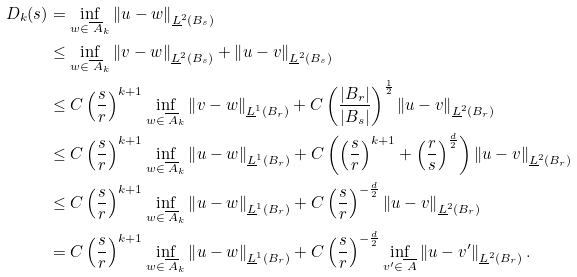Convert formula to latex. <formula><loc_0><loc_0><loc_500><loc_500>D _ { k } ( s ) & = \inf _ { w \in \overline { \ A } _ { k } } \left \| u - w \right \| _ { \underline { L } ^ { 2 } ( B _ { s } ) } \\ & \leq \inf _ { w \in \overline { \ A } _ { k } } \left \| v - w \right \| _ { \underline { L } ^ { 2 } ( B _ { s } ) } + \left \| u - v \right \| _ { \underline { L } ^ { 2 } ( B _ { s } ) } \\ & \leq C \left ( \frac { s } { r } \right ) ^ { k + 1 } \inf _ { w \in \overline { \ A } _ { k } } \left \| v - w \right \| _ { \underline { L } ^ { 1 } ( B _ { r } ) } + C \left ( \frac { | B _ { r } | } { | B _ { s } | } \right ) ^ { \frac { 1 } { 2 } } \left \| u - v \right \| _ { \underline { L } ^ { 2 } ( B _ { r } ) } \\ & \leq C \left ( \frac { s } { r } \right ) ^ { k + 1 } \inf _ { w \in \overline { \ A } _ { k } } \left \| u - w \right \| _ { \underline { L } ^ { 1 } ( B _ { r } ) } + C \left ( \left ( \frac { s } { r } \right ) ^ { k + 1 } + \left ( \frac { r } { s } \right ) ^ { \frac { d } { 2 } } \right ) \left \| u - v \right \| _ { \underline { L } ^ { 2 } ( B _ { r } ) } \\ & \leq C \left ( \frac { s } { r } \right ) ^ { k + 1 } \inf _ { w \in \overline { \ A } _ { k } } \left \| u - w \right \| _ { \underline { L } ^ { 1 } ( B _ { r } ) } + C \left ( \frac { s } { r } \right ) ^ { - \frac { d } { 2 } } \left \| u - v \right \| _ { \underline { L } ^ { 2 } ( B _ { r } ) } \\ & = C \left ( \frac { s } { r } \right ) ^ { k + 1 } \inf _ { w \in \overline { \ A } _ { k } } \left \| u - w \right \| _ { \underline { L } ^ { 1 } ( B _ { r } ) } + C \left ( \frac { s } { r } \right ) ^ { - \frac { d } { 2 } } \inf _ { v ^ { \prime } \in \overline { \ A } } \left \| u - v ^ { \prime } \right \| _ { \underline { L } ^ { 2 } ( B _ { r } ) } .</formula> 